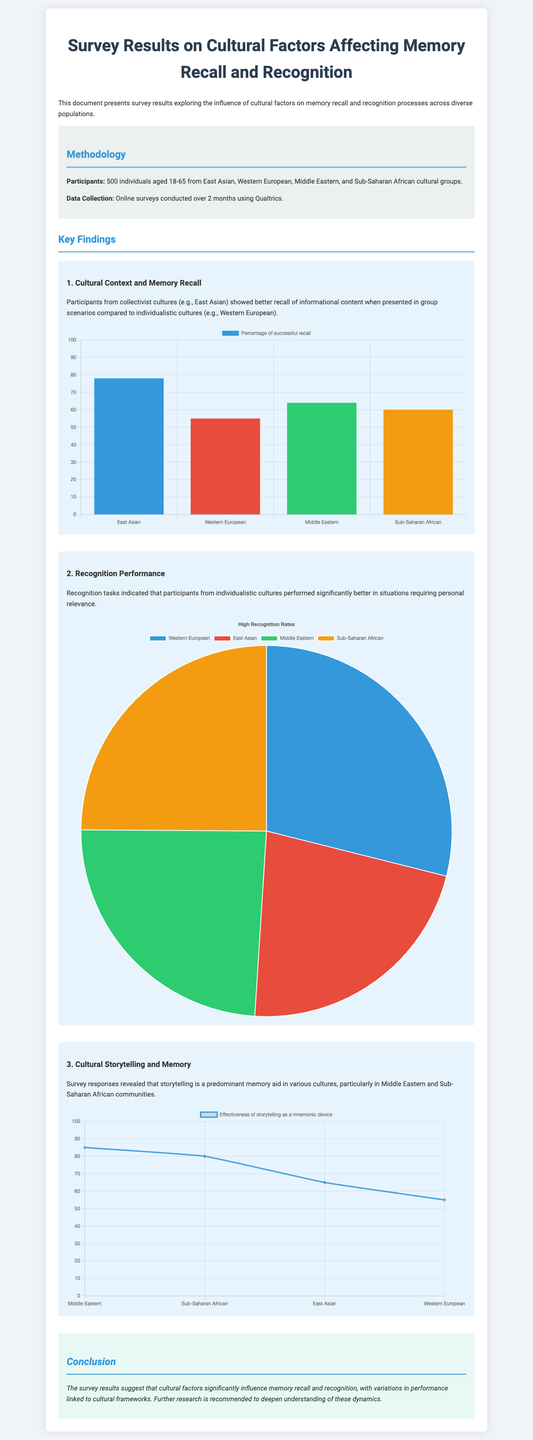What was the sample size of the survey? The document states that 500 individuals participated in the survey.
Answer: 500 Which cultural group showed the highest percentage of successful recall? The recall chart indicates that East Asian participants had the highest percentage of successful recall at 78%.
Answer: 78% What type of chart displays recognition performance? The document indicates that recognition performance is displayed using a pie chart.
Answer: Pie chart Which cultural group is shown to have a lower effectiveness of storytelling as a mnemonic device? The line chart shows that Western European participants have a lower effectiveness at 55%.
Answer: 55% What was the percentage of successful recall for Western European participants? The successful recall percentage for Western European participants was outlined in the bar chart, showing a value of 55%.
Answer: 55% What does the document recommend for further research? The conclusion suggests further research is recommended to deepen understanding of the cultural influences on memory dynamics.
Answer: Further research Which cultural group performed best in recognition tasks? The pie chart indicates that Western European participants performed best in recognition tasks with a percentage of 72%.
Answer: 72% What is the primary memory aid mentioned for Middle Eastern and Sub-Saharan African communities? The document mentions that storytelling is a predominant memory aid for these communities.
Answer: Storytelling 